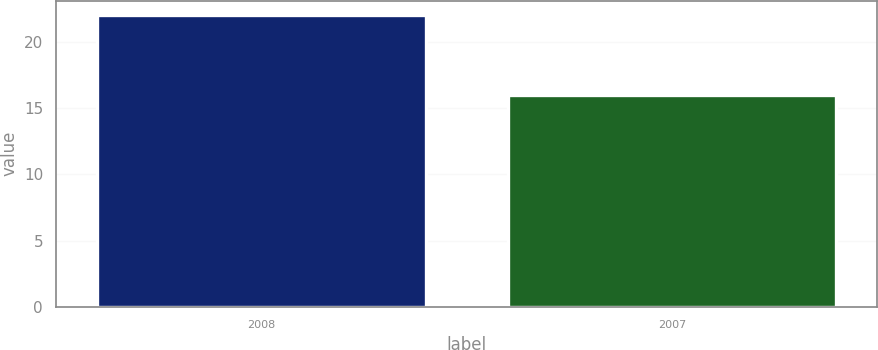<chart> <loc_0><loc_0><loc_500><loc_500><bar_chart><fcel>2008<fcel>2007<nl><fcel>22<fcel>16<nl></chart> 